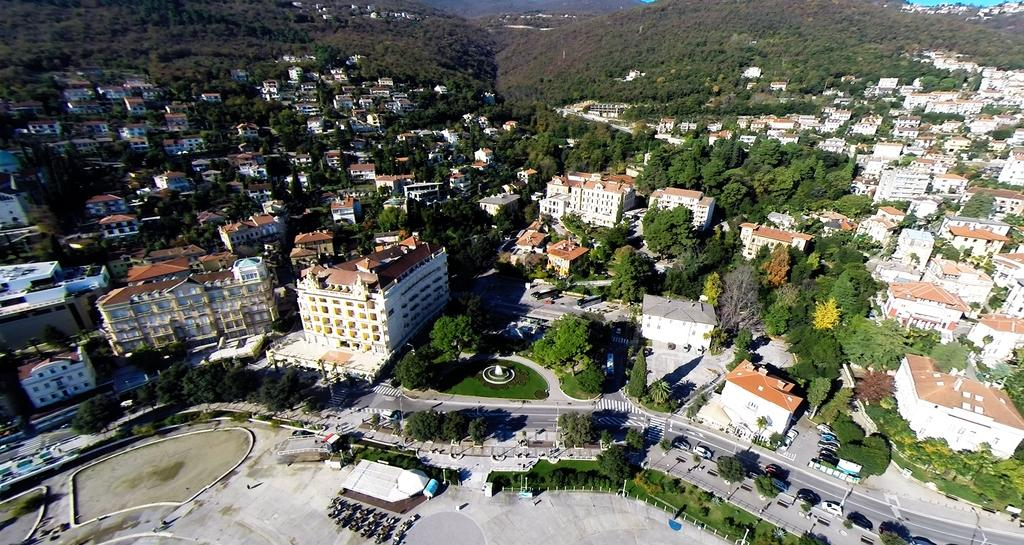What type of structures can be seen in the image? There are many buildings in the image. What natural elements are present in the image? There are trees, grass, and hills in the image. What type of transportation infrastructure is visible in the image? There is a road in the image, and vehicles are on the road. What other objects can be seen in the image? There are poles, plants, and possibly a road sign in the image. What type of door can be seen on the pot in the image? There is no pot or door present in the image. How is the cream being used in the image? There is no cream present in the image. 